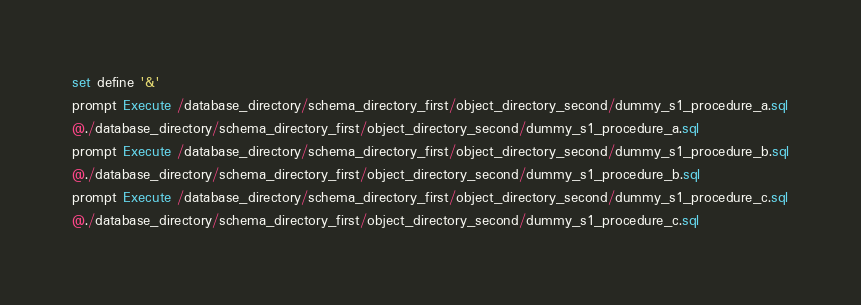Convert code to text. <code><loc_0><loc_0><loc_500><loc_500><_SQL_>set define '&'
prompt Execute /database_directory/schema_directory_first/object_directory_second/dummy_s1_procedure_a.sql
@./database_directory/schema_directory_first/object_directory_second/dummy_s1_procedure_a.sql
prompt Execute /database_directory/schema_directory_first/object_directory_second/dummy_s1_procedure_b.sql
@./database_directory/schema_directory_first/object_directory_second/dummy_s1_procedure_b.sql
prompt Execute /database_directory/schema_directory_first/object_directory_second/dummy_s1_procedure_c.sql
@./database_directory/schema_directory_first/object_directory_second/dummy_s1_procedure_c.sql
</code> 